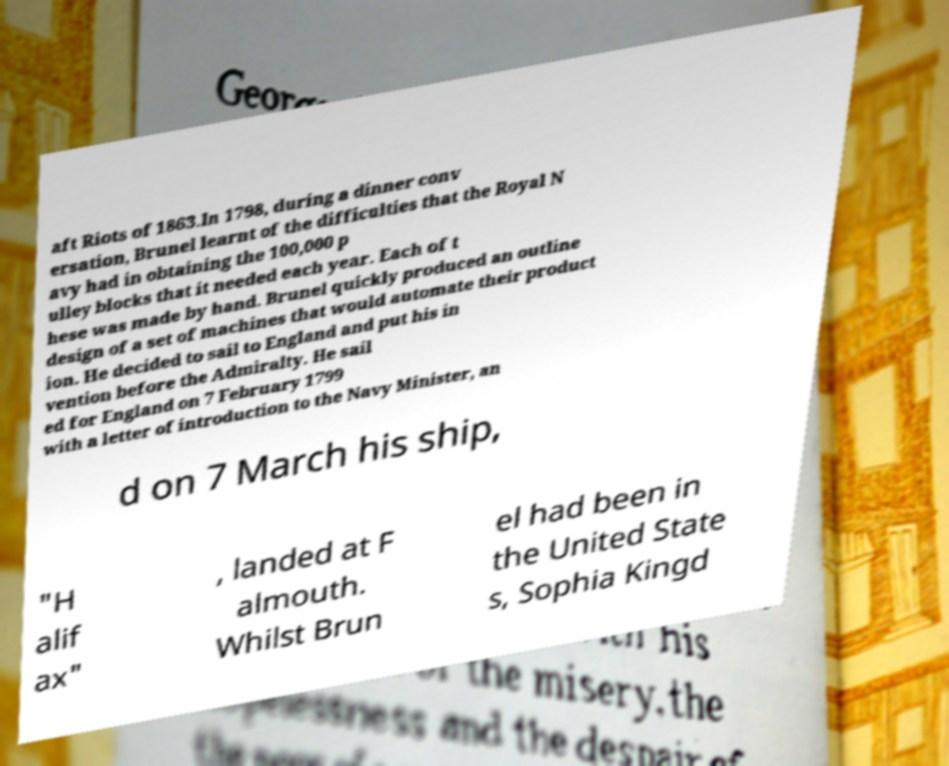Could you assist in decoding the text presented in this image and type it out clearly? aft Riots of 1863.In 1798, during a dinner conv ersation, Brunel learnt of the difficulties that the Royal N avy had in obtaining the 100,000 p ulley blocks that it needed each year. Each of t hese was made by hand. Brunel quickly produced an outline design of a set of machines that would automate their product ion. He decided to sail to England and put his in vention before the Admiralty. He sail ed for England on 7 February 1799 with a letter of introduction to the Navy Minister, an d on 7 March his ship, "H alif ax" , landed at F almouth. Whilst Brun el had been in the United State s, Sophia Kingd 